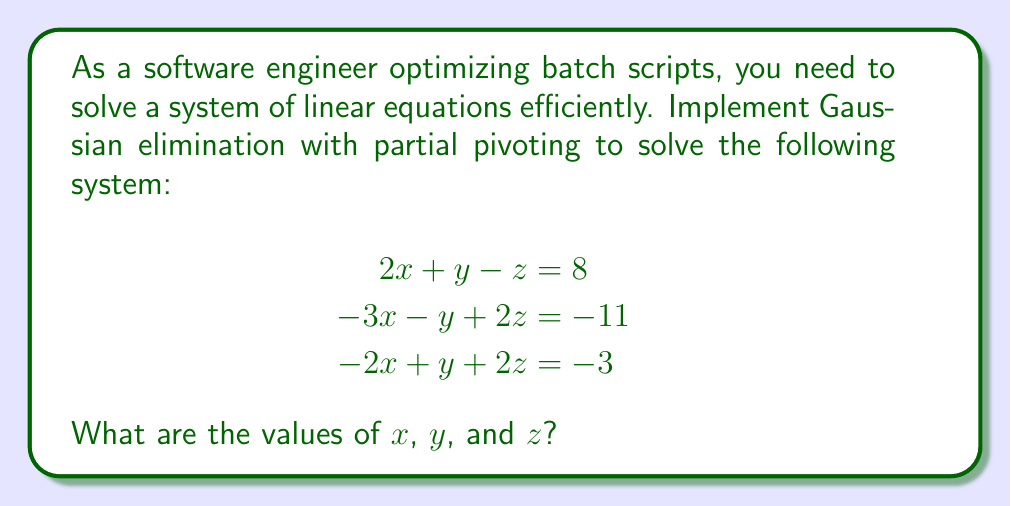Show me your answer to this math problem. Let's solve this system using Gaussian elimination with partial pivoting:

1) First, write the augmented matrix:

   $$
   \begin{bmatrix}
   2 & 1 & -1 & | & 8 \\
   -3 & -1 & 2 & | & -11 \\
   -2 & 1 & 2 & | & -3
   \end{bmatrix}
   $$

2) For each column, we'll choose the pivot as the largest absolute value in that column below the diagonal.

3) For the first column, the largest value is already in the first row, so no swap is needed.

4) Eliminate the first variable in the second and third rows:
   
   R2 = R2 + (3/2)R1
   R3 = R3 + R1

   $$
   \begin{bmatrix}
   2 & 1 & -1 & | & 8 \\
   0 & 0.5 & 0.5 & | & 1 \\
   0 & 2 & 1 & | & 5
   \end{bmatrix}
   $$

5) For the second column, swap R2 and R3:

   $$
   \begin{bmatrix}
   2 & 1 & -1 & | & 8 \\
   0 & 2 & 1 & | & 5 \\
   0 & 0.5 & 0.5 & | & 1
   \end{bmatrix}
   $$

6) Eliminate the second variable in the third row:
   
   R3 = R3 - 0.25R2

   $$
   \begin{bmatrix}
   2 & 1 & -1 & | & 8 \\
   0 & 2 & 1 & | & 5 \\
   0 & 0 & 0.25 & | & -0.25
   \end{bmatrix}
   $$

7) Now we have an upper triangular matrix. Solve by back-substitution:

   $z = -0.25 / 0.25 = -1$
   $y = (5 - 1) / 2 = 2$
   $x = (8 - 2 + 1) / 2 = 3.5$
Answer: $x = 3.5$, $y = 2$, $z = -1$ 